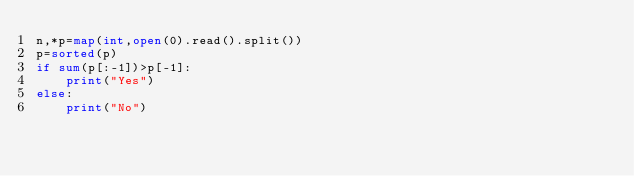<code> <loc_0><loc_0><loc_500><loc_500><_Python_>n,*p=map(int,open(0).read().split())
p=sorted(p)
if sum(p[:-1])>p[-1]:
    print("Yes")
else:
    print("No")</code> 